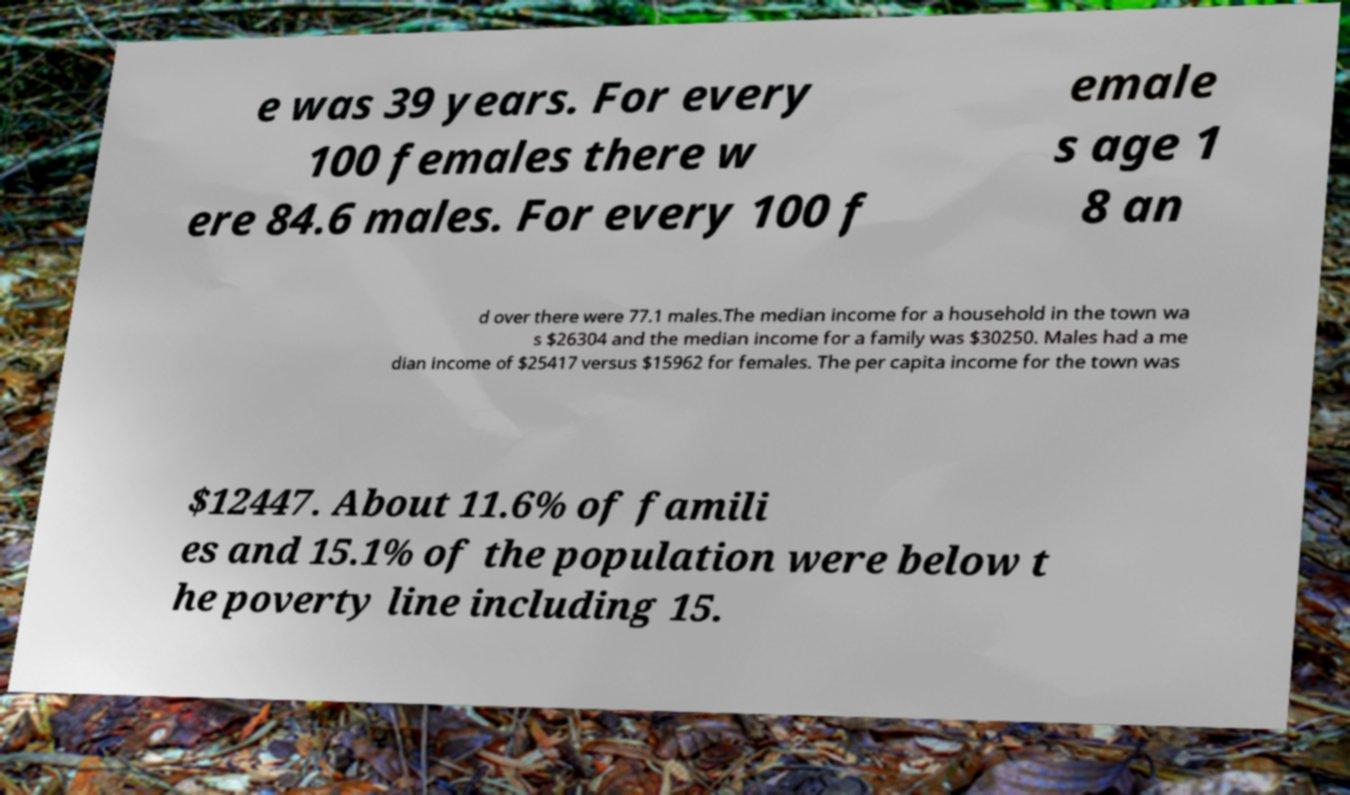For documentation purposes, I need the text within this image transcribed. Could you provide that? e was 39 years. For every 100 females there w ere 84.6 males. For every 100 f emale s age 1 8 an d over there were 77.1 males.The median income for a household in the town wa s $26304 and the median income for a family was $30250. Males had a me dian income of $25417 versus $15962 for females. The per capita income for the town was $12447. About 11.6% of famili es and 15.1% of the population were below t he poverty line including 15. 